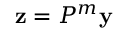Convert formula to latex. <formula><loc_0><loc_0><loc_500><loc_500>z = P ^ { m } y</formula> 